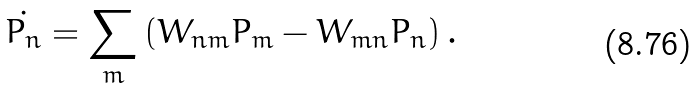Convert formula to latex. <formula><loc_0><loc_0><loc_500><loc_500>\dot { P _ { n } } = \sum _ { m } \left ( W _ { n m } P _ { m } - W _ { m n } P _ { n } \right ) .</formula> 